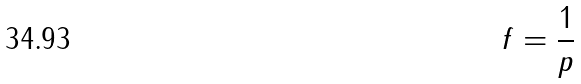Convert formula to latex. <formula><loc_0><loc_0><loc_500><loc_500>f = { \frac { 1 } { p } }</formula> 